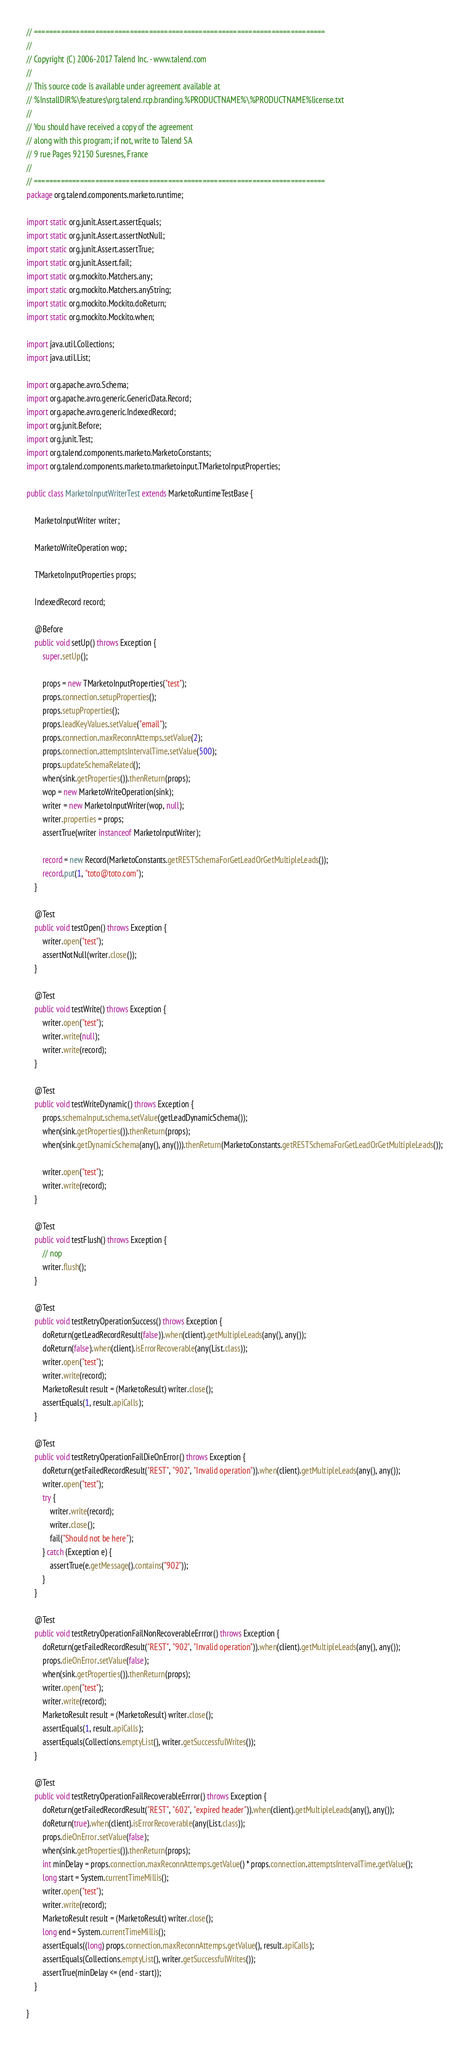Convert code to text. <code><loc_0><loc_0><loc_500><loc_500><_Java_>// ============================================================================
//
// Copyright (C) 2006-2017 Talend Inc. - www.talend.com
//
// This source code is available under agreement available at
// %InstallDIR%\features\org.talend.rcp.branding.%PRODUCTNAME%\%PRODUCTNAME%license.txt
//
// You should have received a copy of the agreement
// along with this program; if not, write to Talend SA
// 9 rue Pages 92150 Suresnes, France
//
// ============================================================================
package org.talend.components.marketo.runtime;

import static org.junit.Assert.assertEquals;
import static org.junit.Assert.assertNotNull;
import static org.junit.Assert.assertTrue;
import static org.junit.Assert.fail;
import static org.mockito.Matchers.any;
import static org.mockito.Matchers.anyString;
import static org.mockito.Mockito.doReturn;
import static org.mockito.Mockito.when;

import java.util.Collections;
import java.util.List;

import org.apache.avro.Schema;
import org.apache.avro.generic.GenericData.Record;
import org.apache.avro.generic.IndexedRecord;
import org.junit.Before;
import org.junit.Test;
import org.talend.components.marketo.MarketoConstants;
import org.talend.components.marketo.tmarketoinput.TMarketoInputProperties;

public class MarketoInputWriterTest extends MarketoRuntimeTestBase {

    MarketoInputWriter writer;

    MarketoWriteOperation wop;

    TMarketoInputProperties props;

    IndexedRecord record;

    @Before
    public void setUp() throws Exception {
        super.setUp();

        props = new TMarketoInputProperties("test");
        props.connection.setupProperties();
        props.setupProperties();
        props.leadKeyValues.setValue("email");
        props.connection.maxReconnAttemps.setValue(2);
        props.connection.attemptsIntervalTime.setValue(500);
        props.updateSchemaRelated();
        when(sink.getProperties()).thenReturn(props);
        wop = new MarketoWriteOperation(sink);
        writer = new MarketoInputWriter(wop, null);
        writer.properties = props;
        assertTrue(writer instanceof MarketoInputWriter);

        record = new Record(MarketoConstants.getRESTSchemaForGetLeadOrGetMultipleLeads());
        record.put(1, "toto@toto.com");
    }

    @Test
    public void testOpen() throws Exception {
        writer.open("test");
        assertNotNull(writer.close());
    }

    @Test
    public void testWrite() throws Exception {
        writer.open("test");
        writer.write(null);
        writer.write(record);
    }

    @Test
    public void testWriteDynamic() throws Exception {
        props.schemaInput.schema.setValue(getLeadDynamicSchema());
        when(sink.getProperties()).thenReturn(props);
        when(sink.getDynamicSchema(any(), any())).thenReturn(MarketoConstants.getRESTSchemaForGetLeadOrGetMultipleLeads());

        writer.open("test");
        writer.write(record);
    }

    @Test
    public void testFlush() throws Exception {
        // nop
        writer.flush();
    }

    @Test
    public void testRetryOperationSuccess() throws Exception {
        doReturn(getLeadRecordResult(false)).when(client).getMultipleLeads(any(), any());
        doReturn(false).when(client).isErrorRecoverable(any(List.class));
        writer.open("test");
        writer.write(record);
        MarketoResult result = (MarketoResult) writer.close();
        assertEquals(1, result.apiCalls);
    }

    @Test
    public void testRetryOperationFailDieOnError() throws Exception {
        doReturn(getFailedRecordResult("REST", "902", "Invalid operation")).when(client).getMultipleLeads(any(), any());
        writer.open("test");
        try {
            writer.write(record);
            writer.close();
            fail("Should not be here");
        } catch (Exception e) {
            assertTrue(e.getMessage().contains("902"));
        }
    }

    @Test
    public void testRetryOperationFailNonRecoverableErrror() throws Exception {
        doReturn(getFailedRecordResult("REST", "902", "Invalid operation")).when(client).getMultipleLeads(any(), any());
        props.dieOnError.setValue(false);
        when(sink.getProperties()).thenReturn(props);
        writer.open("test");
        writer.write(record);
        MarketoResult result = (MarketoResult) writer.close();
        assertEquals(1, result.apiCalls);
        assertEquals(Collections.emptyList(), writer.getSuccessfulWrites());
    }

    @Test
    public void testRetryOperationFailRecoverableErrror() throws Exception {
        doReturn(getFailedRecordResult("REST", "602", "expired header")).when(client).getMultipleLeads(any(), any());
        doReturn(true).when(client).isErrorRecoverable(any(List.class));
        props.dieOnError.setValue(false);
        when(sink.getProperties()).thenReturn(props);
        int minDelay = props.connection.maxReconnAttemps.getValue() * props.connection.attemptsIntervalTime.getValue();
        long start = System.currentTimeMillis();
        writer.open("test");
        writer.write(record);
        MarketoResult result = (MarketoResult) writer.close();
        long end = System.currentTimeMillis();
        assertEquals((long) props.connection.maxReconnAttemps.getValue(), result.apiCalls);
        assertEquals(Collections.emptyList(), writer.getSuccessfulWrites());
        assertTrue(minDelay <= (end - start));
    }

}
</code> 